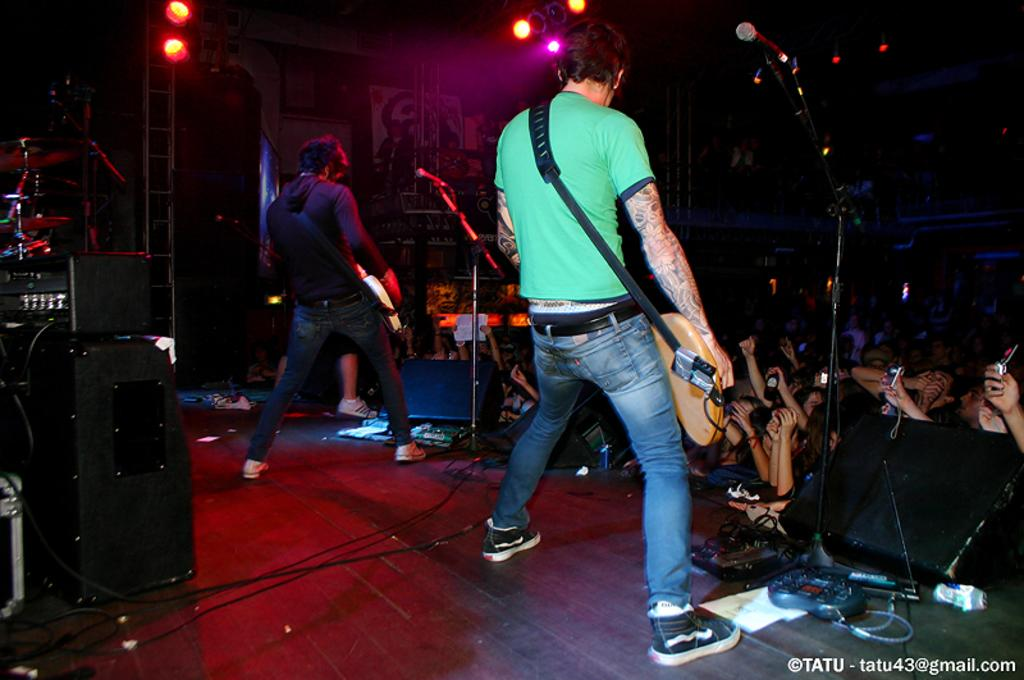What is happening on the stage in the image? There are two people on the stage, and they are holding musical instruments. What are the other people on the floor doing? The facts provided do not specify what the people on the floor are doing. Can you describe the musical instruments being held by the people on the stage? The facts provided do not specify the type of musical instruments being held by the people on the stage. How many babies are crawling on the stage in the image? There are no babies present in the image; it features two people holding musical instruments on the stage. What type of vegetable is being used as a prop by the people on the stage? There is no vegetable present in the image; it features people holding musical instruments on the stage. 